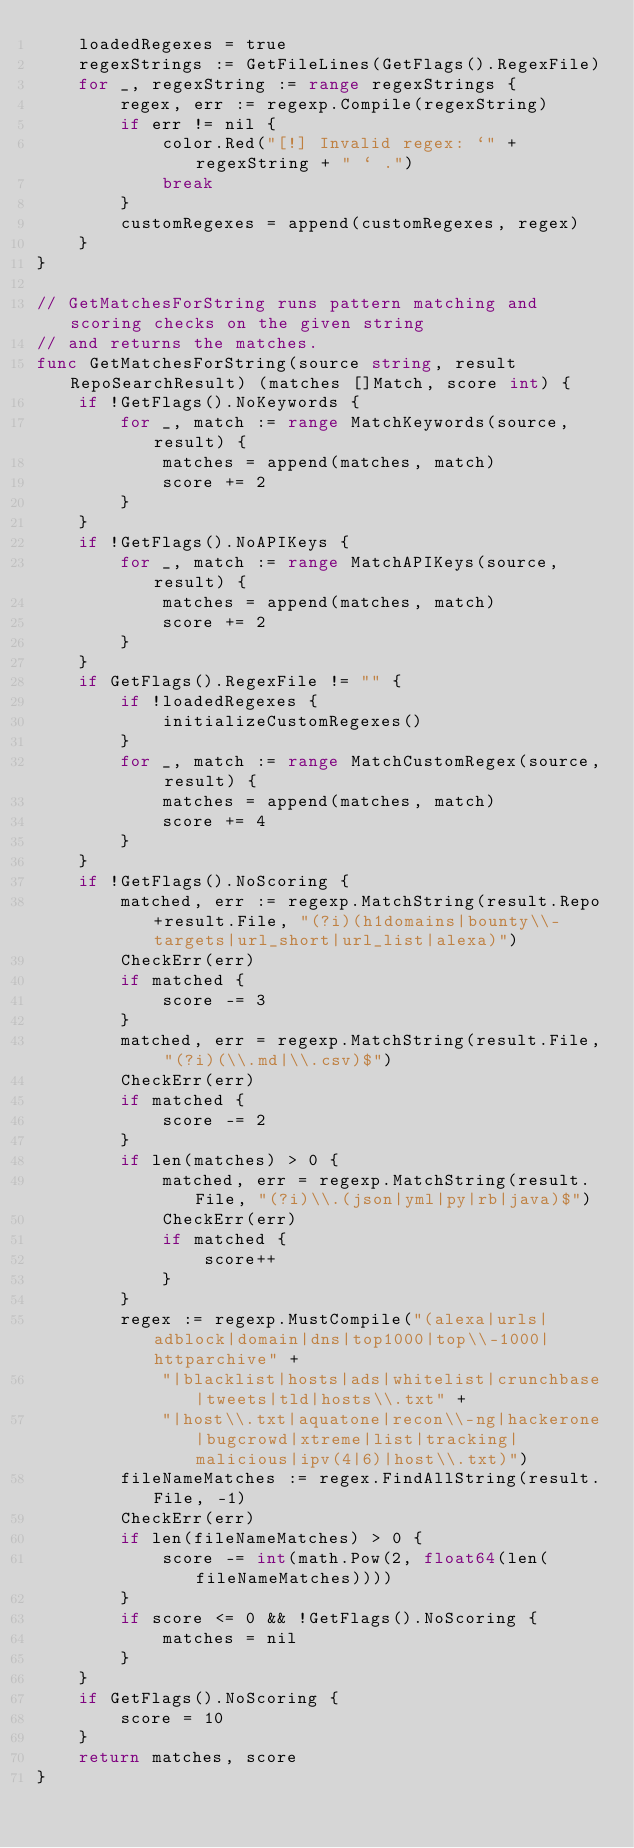Convert code to text. <code><loc_0><loc_0><loc_500><loc_500><_Go_>	loadedRegexes = true
	regexStrings := GetFileLines(GetFlags().RegexFile)
	for _, regexString := range regexStrings {
		regex, err := regexp.Compile(regexString)
		if err != nil {
			color.Red("[!] Invalid regex: `" + regexString + " ` .")
			break
		}
		customRegexes = append(customRegexes, regex)
	}
}

// GetMatchesForString runs pattern matching and scoring checks on the given string
// and returns the matches.
func GetMatchesForString(source string, result RepoSearchResult) (matches []Match, score int) {
	if !GetFlags().NoKeywords {
		for _, match := range MatchKeywords(source, result) {
			matches = append(matches, match)
			score += 2
		}
	}
	if !GetFlags().NoAPIKeys {
		for _, match := range MatchAPIKeys(source, result) {
			matches = append(matches, match)
			score += 2
		}
	}
	if GetFlags().RegexFile != "" {
		if !loadedRegexes {
			initializeCustomRegexes()
		}
		for _, match := range MatchCustomRegex(source, result) {
			matches = append(matches, match)
			score += 4
		}
	}
	if !GetFlags().NoScoring {
		matched, err := regexp.MatchString(result.Repo+result.File, "(?i)(h1domains|bounty\\-targets|url_short|url_list|alexa)")
		CheckErr(err)
		if matched {
			score -= 3
		}
		matched, err = regexp.MatchString(result.File, "(?i)(\\.md|\\.csv)$")
		CheckErr(err)
		if matched {
			score -= 2
		}
		if len(matches) > 0 {
			matched, err = regexp.MatchString(result.File, "(?i)\\.(json|yml|py|rb|java)$")
			CheckErr(err)
			if matched {
				score++
			}
		}
		regex := regexp.MustCompile("(alexa|urls|adblock|domain|dns|top1000|top\\-1000|httparchive" +
			"|blacklist|hosts|ads|whitelist|crunchbase|tweets|tld|hosts\\.txt" +
			"|host\\.txt|aquatone|recon\\-ng|hackerone|bugcrowd|xtreme|list|tracking|malicious|ipv(4|6)|host\\.txt)")
		fileNameMatches := regex.FindAllString(result.File, -1)
		CheckErr(err)
		if len(fileNameMatches) > 0 {
			score -= int(math.Pow(2, float64(len(fileNameMatches))))
		}
		if score <= 0 && !GetFlags().NoScoring {
			matches = nil
		}
	}
	if GetFlags().NoScoring {
		score = 10
	}
	return matches, score
}
</code> 